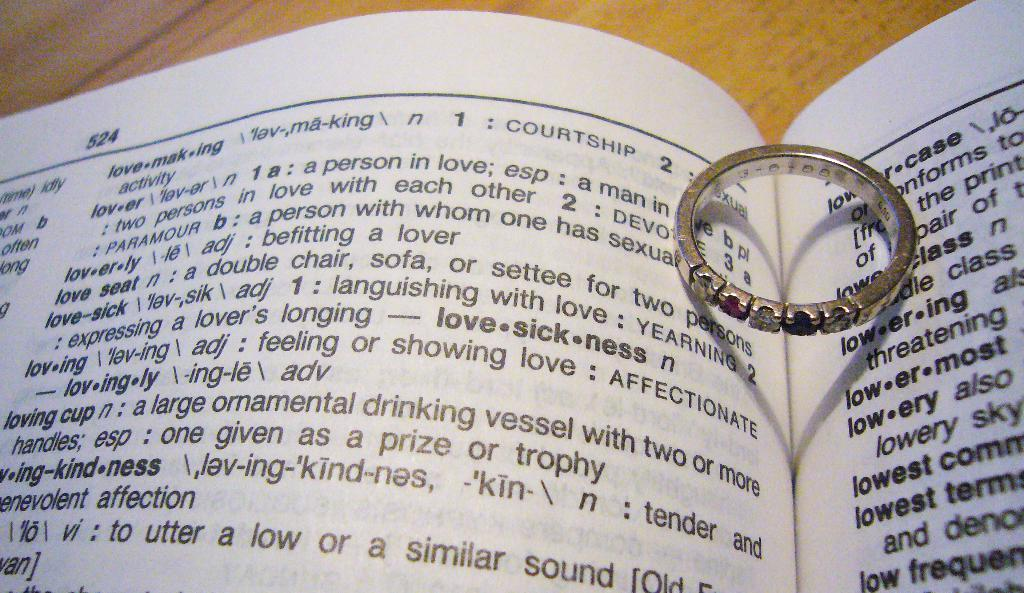<image>
Summarize the visual content of the image. A ring lays on an opened book with page 524 visible. 